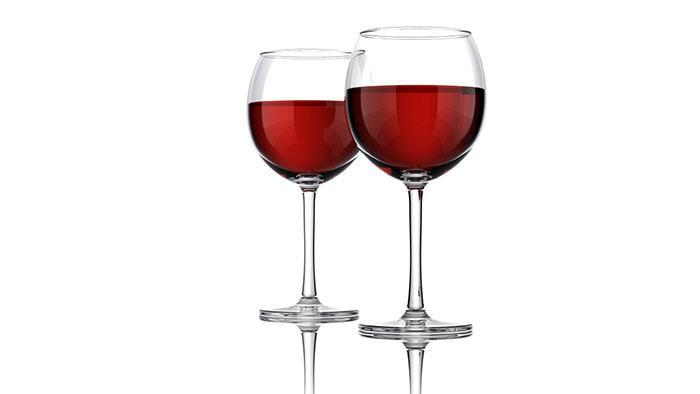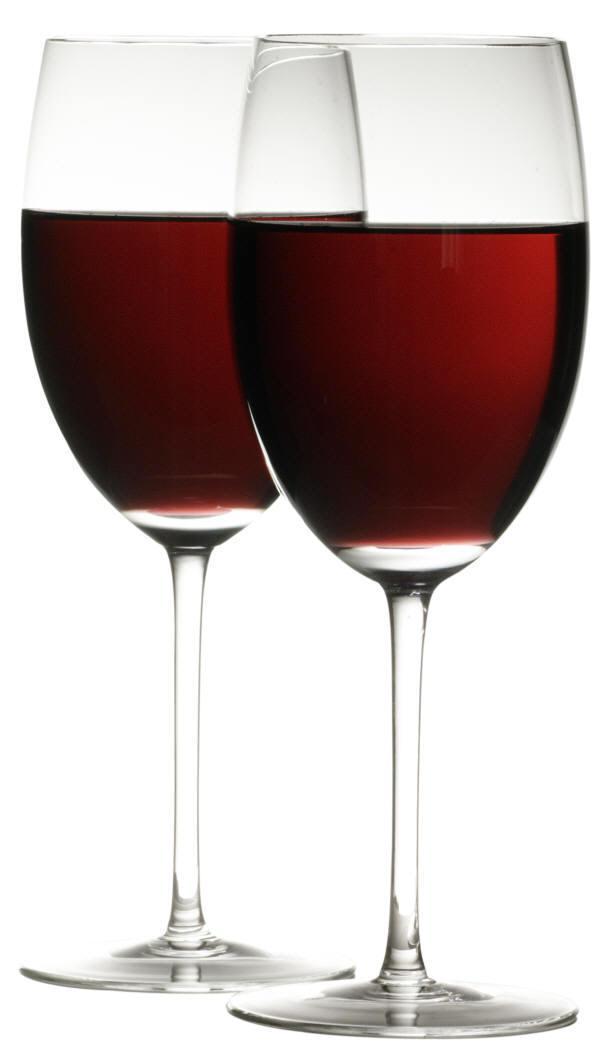The first image is the image on the left, the second image is the image on the right. Given the left and right images, does the statement "Two glasses are angled toward each other in one of the images." hold true? Answer yes or no. No. The first image is the image on the left, the second image is the image on the right. For the images shown, is this caption "There is one pair of overlapping glasses containing level liquids, and one pair of glasses that do not overlap." true? Answer yes or no. No. 